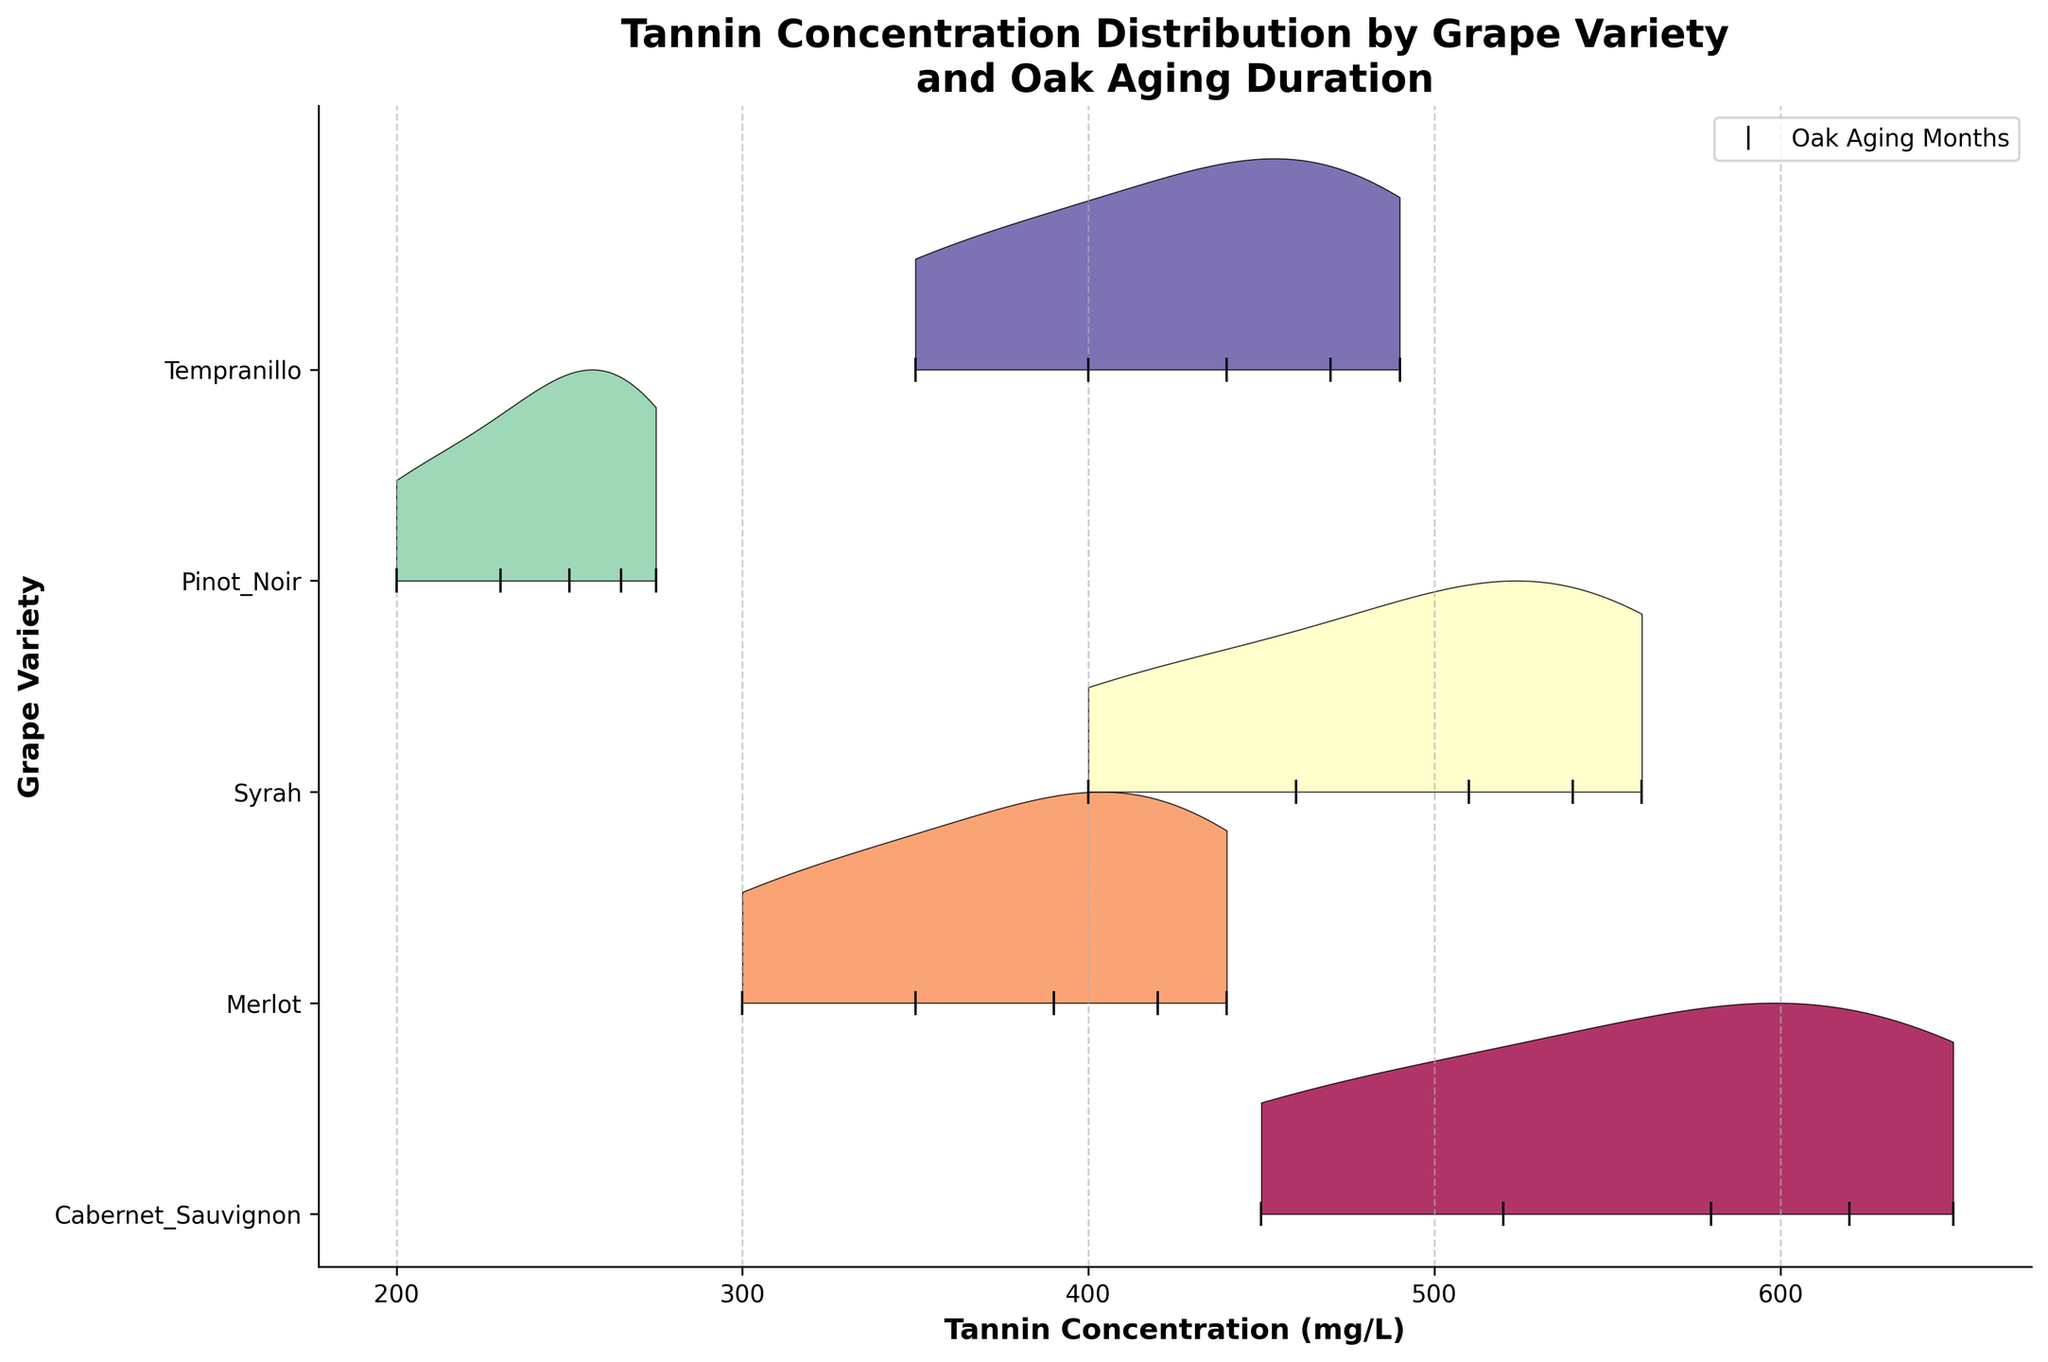What's the title of the figure? The title is located at the top of the figure and provides an overview of what the plot represents.
Answer: Tannin Concentration Distribution by Grape Variety and Oak Aging Duration What's the x-axis label in the figure? The x-axis label, found below the x-axis, indicates what the horizontal axis represents.
Answer: Tannin Concentration (mg/L) Which grape variety has the highest tannin concentration? By looking at the rightmost part of each line from each grape variety, we can identify the peak.
Answer: Cabernet Sauvignon Which grape variety has the lowest tannin concentration without oak aging? Look at the tannin concentrations at Oak Aging of 0 months for all grape varieties and determine the lowest.
Answer: Pinot Noir How do tannin concentrations in Syrah wines change with oak aging duration? Check the positions of the markers for Syrah along the x-axis at each oak aging duration to observe the changes.
Answer: Increase Between Merlot and Tempranillo, which variety shows a greater increase in tannin concentration over the oak aging period? Calculate the difference in tannin concentration from 0 to 24 months for both varieties and compare. Merlot (440-300 = 140), Tempranillo (490-350 = 140).
Answer: Both increase by 140 mg/L Which grape variety shows the least change in tannin concentration after 24 months of oak aging? Calculate the difference in tannin concentration from 0 to 24 months for each grape variety, then find the smallest difference. Pinot Noir (275-200 = 75), compare with other varieties.
Answer: Pinot Noir How are the grape varieties visually distinguished from one another in the plot? To distinguish the varieties, observe the use of different colors and positions along the y-axis in the ridgeline plot.
Answer: Different colors and y-axis positions Would you say that oak aging significantly impacts tannin concentration in all grape varieties? Why or why not? Evaluate the variation in tannin concentration for each variety over the range of oak aging durations. The clear increasing trends indicate significant impact.
Answer: Yes, because tannin concentrations increase for all varieties with more oak aging 